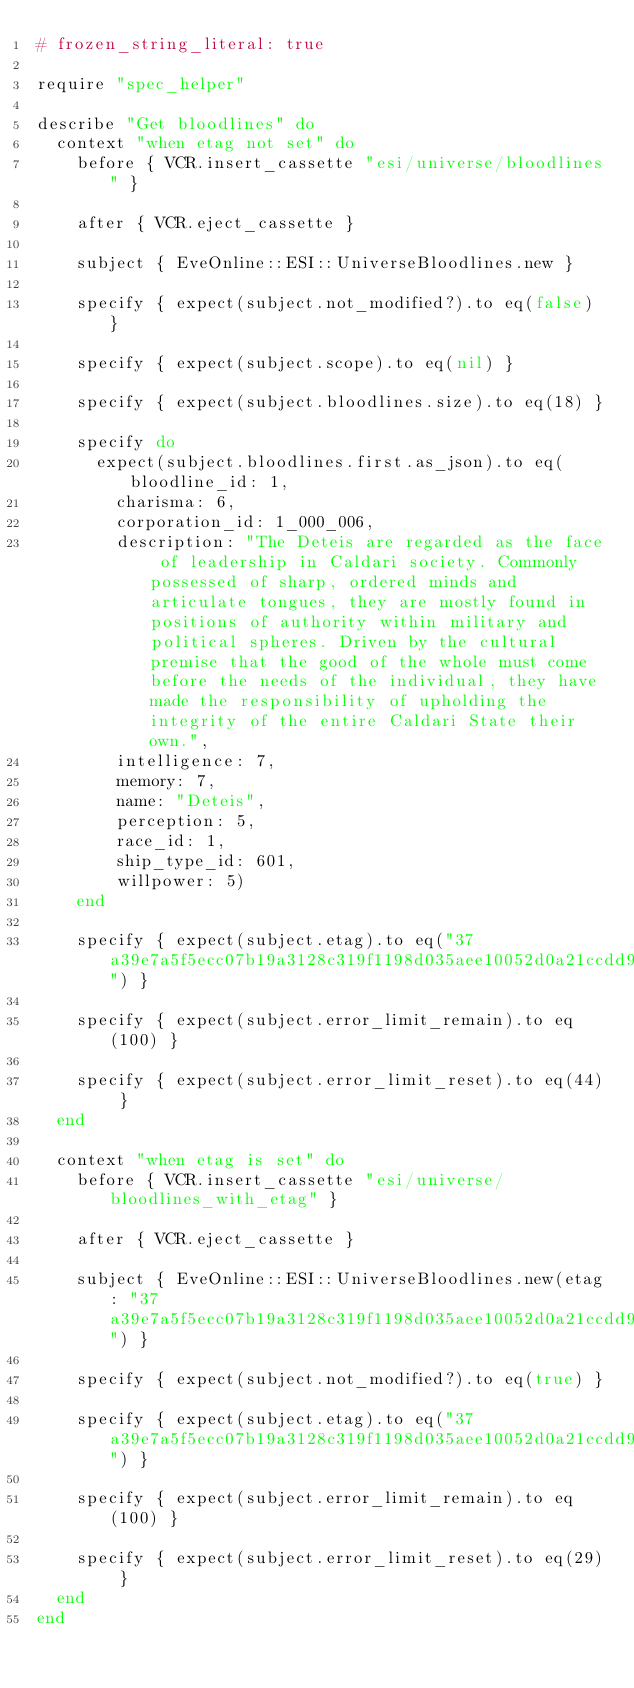<code> <loc_0><loc_0><loc_500><loc_500><_Ruby_># frozen_string_literal: true

require "spec_helper"

describe "Get bloodlines" do
  context "when etag not set" do
    before { VCR.insert_cassette "esi/universe/bloodlines" }

    after { VCR.eject_cassette }

    subject { EveOnline::ESI::UniverseBloodlines.new }

    specify { expect(subject.not_modified?).to eq(false) }

    specify { expect(subject.scope).to eq(nil) }

    specify { expect(subject.bloodlines.size).to eq(18) }

    specify do
      expect(subject.bloodlines.first.as_json).to eq(bloodline_id: 1,
        charisma: 6,
        corporation_id: 1_000_006,
        description: "The Deteis are regarded as the face of leadership in Caldari society. Commonly possessed of sharp, ordered minds and articulate tongues, they are mostly found in positions of authority within military and political spheres. Driven by the cultural premise that the good of the whole must come before the needs of the individual, they have made the responsibility of upholding the integrity of the entire Caldari State their own.",
        intelligence: 7,
        memory: 7,
        name: "Deteis",
        perception: 5,
        race_id: 1,
        ship_type_id: 601,
        willpower: 5)
    end

    specify { expect(subject.etag).to eq("37a39e7a5f5ecc07b19a3128c319f1198d035aee10052d0a21ccdd94") }

    specify { expect(subject.error_limit_remain).to eq(100) }

    specify { expect(subject.error_limit_reset).to eq(44) }
  end

  context "when etag is set" do
    before { VCR.insert_cassette "esi/universe/bloodlines_with_etag" }

    after { VCR.eject_cassette }

    subject { EveOnline::ESI::UniverseBloodlines.new(etag: "37a39e7a5f5ecc07b19a3128c319f1198d035aee10052d0a21ccdd94") }

    specify { expect(subject.not_modified?).to eq(true) }

    specify { expect(subject.etag).to eq("37a39e7a5f5ecc07b19a3128c319f1198d035aee10052d0a21ccdd94") }

    specify { expect(subject.error_limit_remain).to eq(100) }

    specify { expect(subject.error_limit_reset).to eq(29) }
  end
end
</code> 